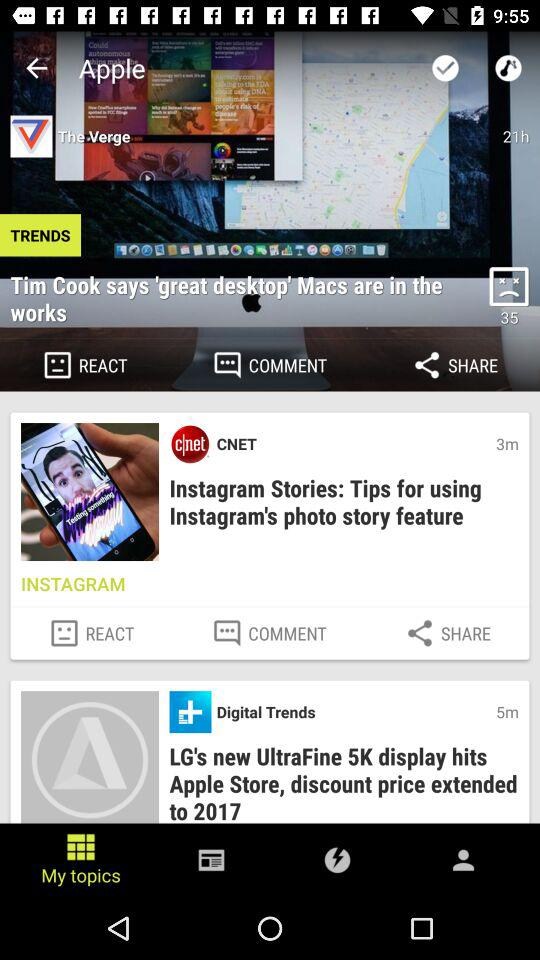What is the name of the user? The name of the user is John. 